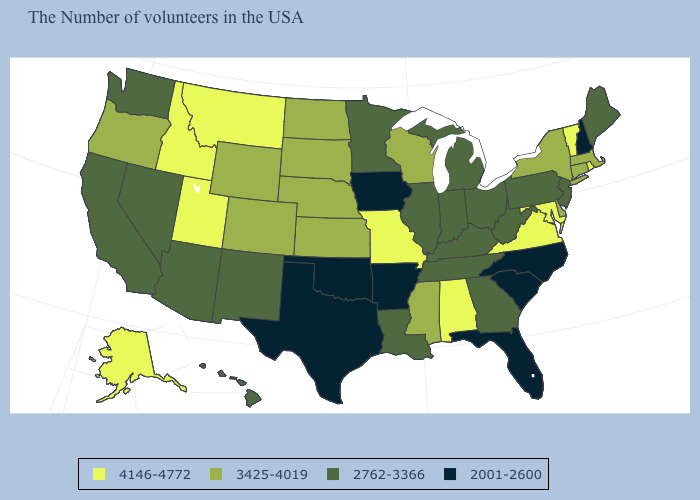What is the highest value in the USA?
Short answer required. 4146-4772. What is the lowest value in the MidWest?
Write a very short answer. 2001-2600. Which states hav the highest value in the West?
Be succinct. Utah, Montana, Idaho, Alaska. How many symbols are there in the legend?
Keep it brief. 4. What is the lowest value in states that border Florida?
Concise answer only. 2762-3366. Name the states that have a value in the range 2762-3366?
Be succinct. Maine, New Jersey, Pennsylvania, West Virginia, Ohio, Georgia, Michigan, Kentucky, Indiana, Tennessee, Illinois, Louisiana, Minnesota, New Mexico, Arizona, Nevada, California, Washington, Hawaii. What is the value of Massachusetts?
Be succinct. 3425-4019. Which states hav the highest value in the South?
Be succinct. Maryland, Virginia, Alabama. What is the value of Oregon?
Short answer required. 3425-4019. Does the map have missing data?
Be succinct. No. What is the highest value in states that border Arkansas?
Quick response, please. 4146-4772. Among the states that border Mississippi , which have the highest value?
Keep it brief. Alabama. Which states hav the highest value in the South?
Be succinct. Maryland, Virginia, Alabama. Does Iowa have the lowest value in the MidWest?
Give a very brief answer. Yes. What is the lowest value in the Northeast?
Write a very short answer. 2001-2600. 